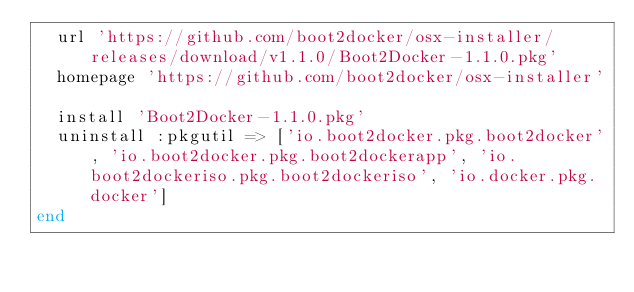Convert code to text. <code><loc_0><loc_0><loc_500><loc_500><_Ruby_>  url 'https://github.com/boot2docker/osx-installer/releases/download/v1.1.0/Boot2Docker-1.1.0.pkg'
  homepage 'https://github.com/boot2docker/osx-installer'

  install 'Boot2Docker-1.1.0.pkg'
  uninstall :pkgutil => ['io.boot2docker.pkg.boot2docker', 'io.boot2docker.pkg.boot2dockerapp', 'io.boot2dockeriso.pkg.boot2dockeriso', 'io.docker.pkg.docker']
end
</code> 